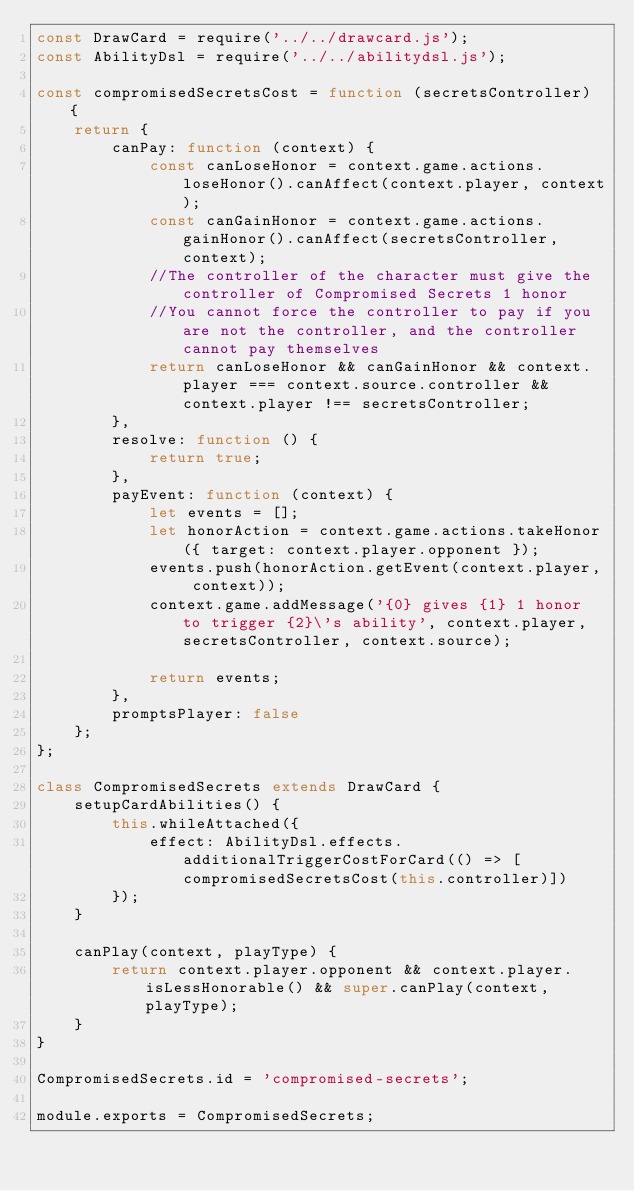<code> <loc_0><loc_0><loc_500><loc_500><_JavaScript_>const DrawCard = require('../../drawcard.js');
const AbilityDsl = require('../../abilitydsl.js');

const compromisedSecretsCost = function (secretsController) {
    return {
        canPay: function (context) {
            const canLoseHonor = context.game.actions.loseHonor().canAffect(context.player, context);
            const canGainHonor = context.game.actions.gainHonor().canAffect(secretsController, context);
            //The controller of the character must give the controller of Compromised Secrets 1 honor
            //You cannot force the controller to pay if you are not the controller, and the controller cannot pay themselves
            return canLoseHonor && canGainHonor && context.player === context.source.controller && context.player !== secretsController;
        },
        resolve: function () {
            return true;
        },
        payEvent: function (context) {
            let events = [];
            let honorAction = context.game.actions.takeHonor({ target: context.player.opponent });
            events.push(honorAction.getEvent(context.player, context));
            context.game.addMessage('{0} gives {1} 1 honor to trigger {2}\'s ability', context.player, secretsController, context.source);

            return events;
        },
        promptsPlayer: false
    };
};

class CompromisedSecrets extends DrawCard {
    setupCardAbilities() {
        this.whileAttached({
            effect: AbilityDsl.effects.additionalTriggerCostForCard(() => [compromisedSecretsCost(this.controller)])
        });
    }

    canPlay(context, playType) {
        return context.player.opponent && context.player.isLessHonorable() && super.canPlay(context, playType);
    }
}

CompromisedSecrets.id = 'compromised-secrets';

module.exports = CompromisedSecrets;
</code> 